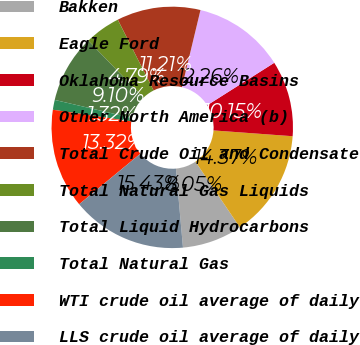Convert chart to OTSL. <chart><loc_0><loc_0><loc_500><loc_500><pie_chart><fcel>Bakken<fcel>Eagle Ford<fcel>Oklahoma Resource Basins<fcel>Other North America (b)<fcel>Total Crude Oil and Condensate<fcel>Total Natural Gas Liquids<fcel>Total Liquid Hydrocarbons<fcel>Total Natural Gas<fcel>WTI crude oil average of daily<fcel>LLS crude oil average of daily<nl><fcel>8.05%<fcel>14.37%<fcel>10.15%<fcel>12.26%<fcel>11.21%<fcel>4.79%<fcel>9.1%<fcel>1.32%<fcel>13.32%<fcel>15.43%<nl></chart> 